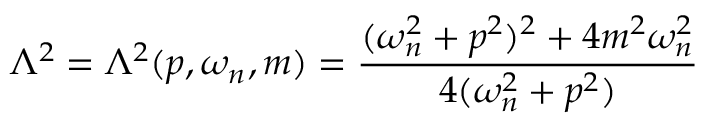Convert formula to latex. <formula><loc_0><loc_0><loc_500><loc_500>\Lambda ^ { 2 } = \Lambda ^ { 2 } ( p , \omega _ { n } , m ) = \frac { ( \omega _ { n } ^ { 2 } + p ^ { 2 } ) ^ { 2 } + 4 m ^ { 2 } \omega _ { n } ^ { 2 } } { 4 ( \omega _ { n } ^ { 2 } + p ^ { 2 } ) }</formula> 